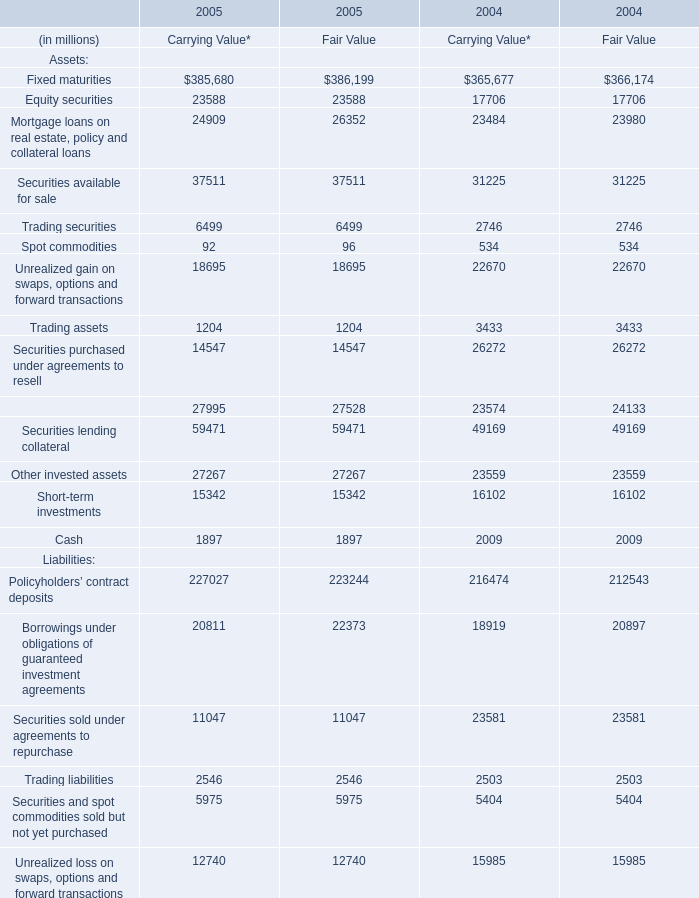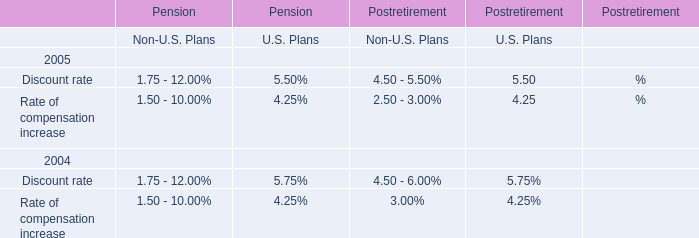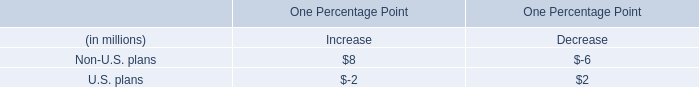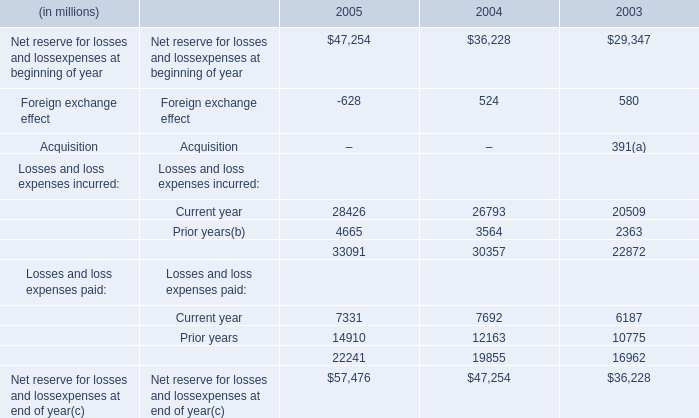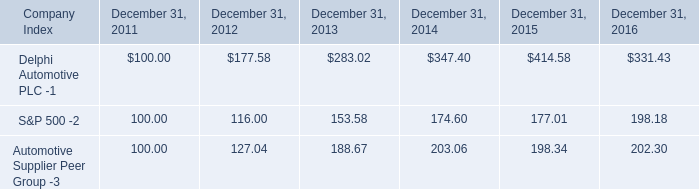What's the increasing rate of Fixed maturities of Fair Value in 2005? 
Computations: ((386199 - 366174) / 366174)
Answer: 0.05469. 